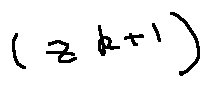Convert formula to latex. <formula><loc_0><loc_0><loc_500><loc_500>( z ^ { k + 1 } )</formula> 